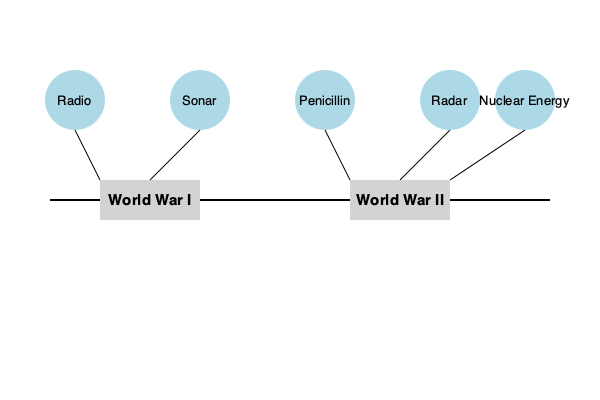Based on the flowchart, which scientific advancement developed during World War I later played a crucial role in the discovery of a life-saving medical treatment during the interwar period? To answer this question, we need to analyze the flowchart and follow these steps:

1. Identify the inventions associated with World War I:
   - Radio
   - Sonar

2. Look at the inventions that appeared between World War I and World War II:
   - Penicillin

3. Consider the potential connections between these inventions:
   - Radio is primarily a communication technology, not directly related to medical treatments.
   - Sonar, while seemingly unrelated, actually played a crucial role in the development of penicillin.

4. Understand the historical context:
   - Sonar technology, developed for detecting submarines, led to improvements in deep tank fermentation techniques.
   - These fermentation techniques were essential for the mass production of penicillin during World War II.

5. Connect the dots:
   - Sonar, invented during World War I, indirectly contributed to the development and mass production of penicillin, a life-saving antibiotic discovered in the interwar period.

This connection demonstrates how a technology developed for warfare (sonar) had unforeseen applications in advancing medical science, highlighting the complex relationship between scientific progress and historical events.
Answer: Sonar 